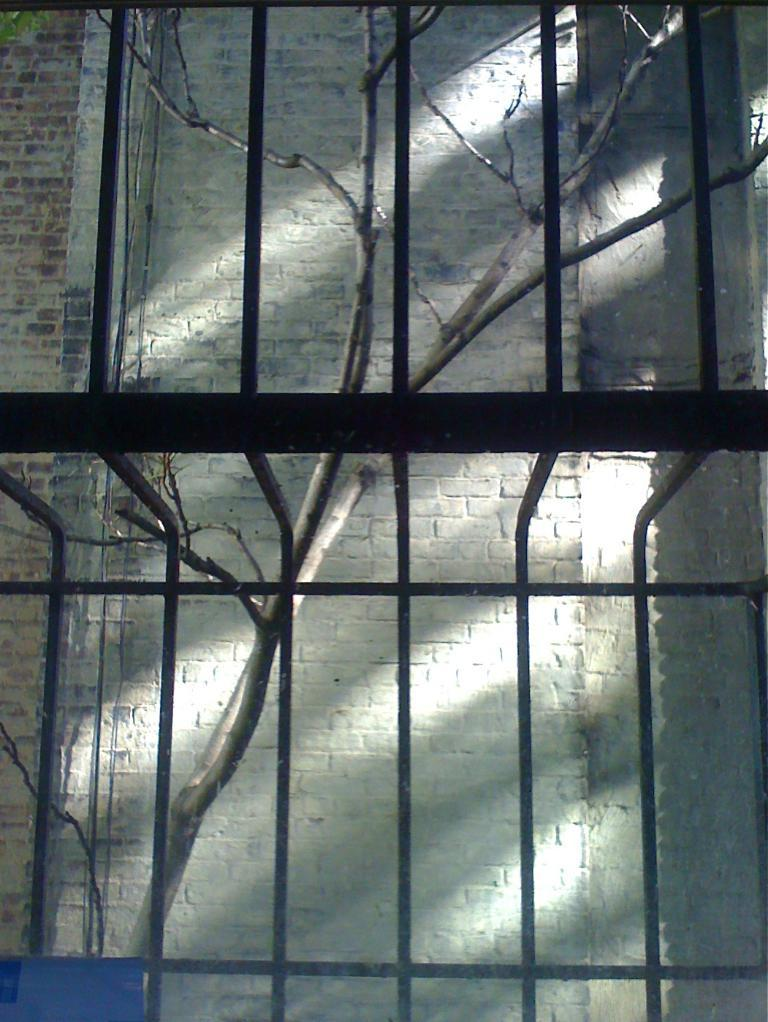What is the main object in the image? There is a grill in the image. What can be seen through the grill? There is a tree and a wall visible through the grill. How many cherries are hanging from the tree visible through the grill? There is no tree with cherries visible in the image; only a tree without any specific fruit mentioned is visible. What type of dress is the grill wearing in the image? The grill is an inanimate object and does not wear any clothing, including a dress. 